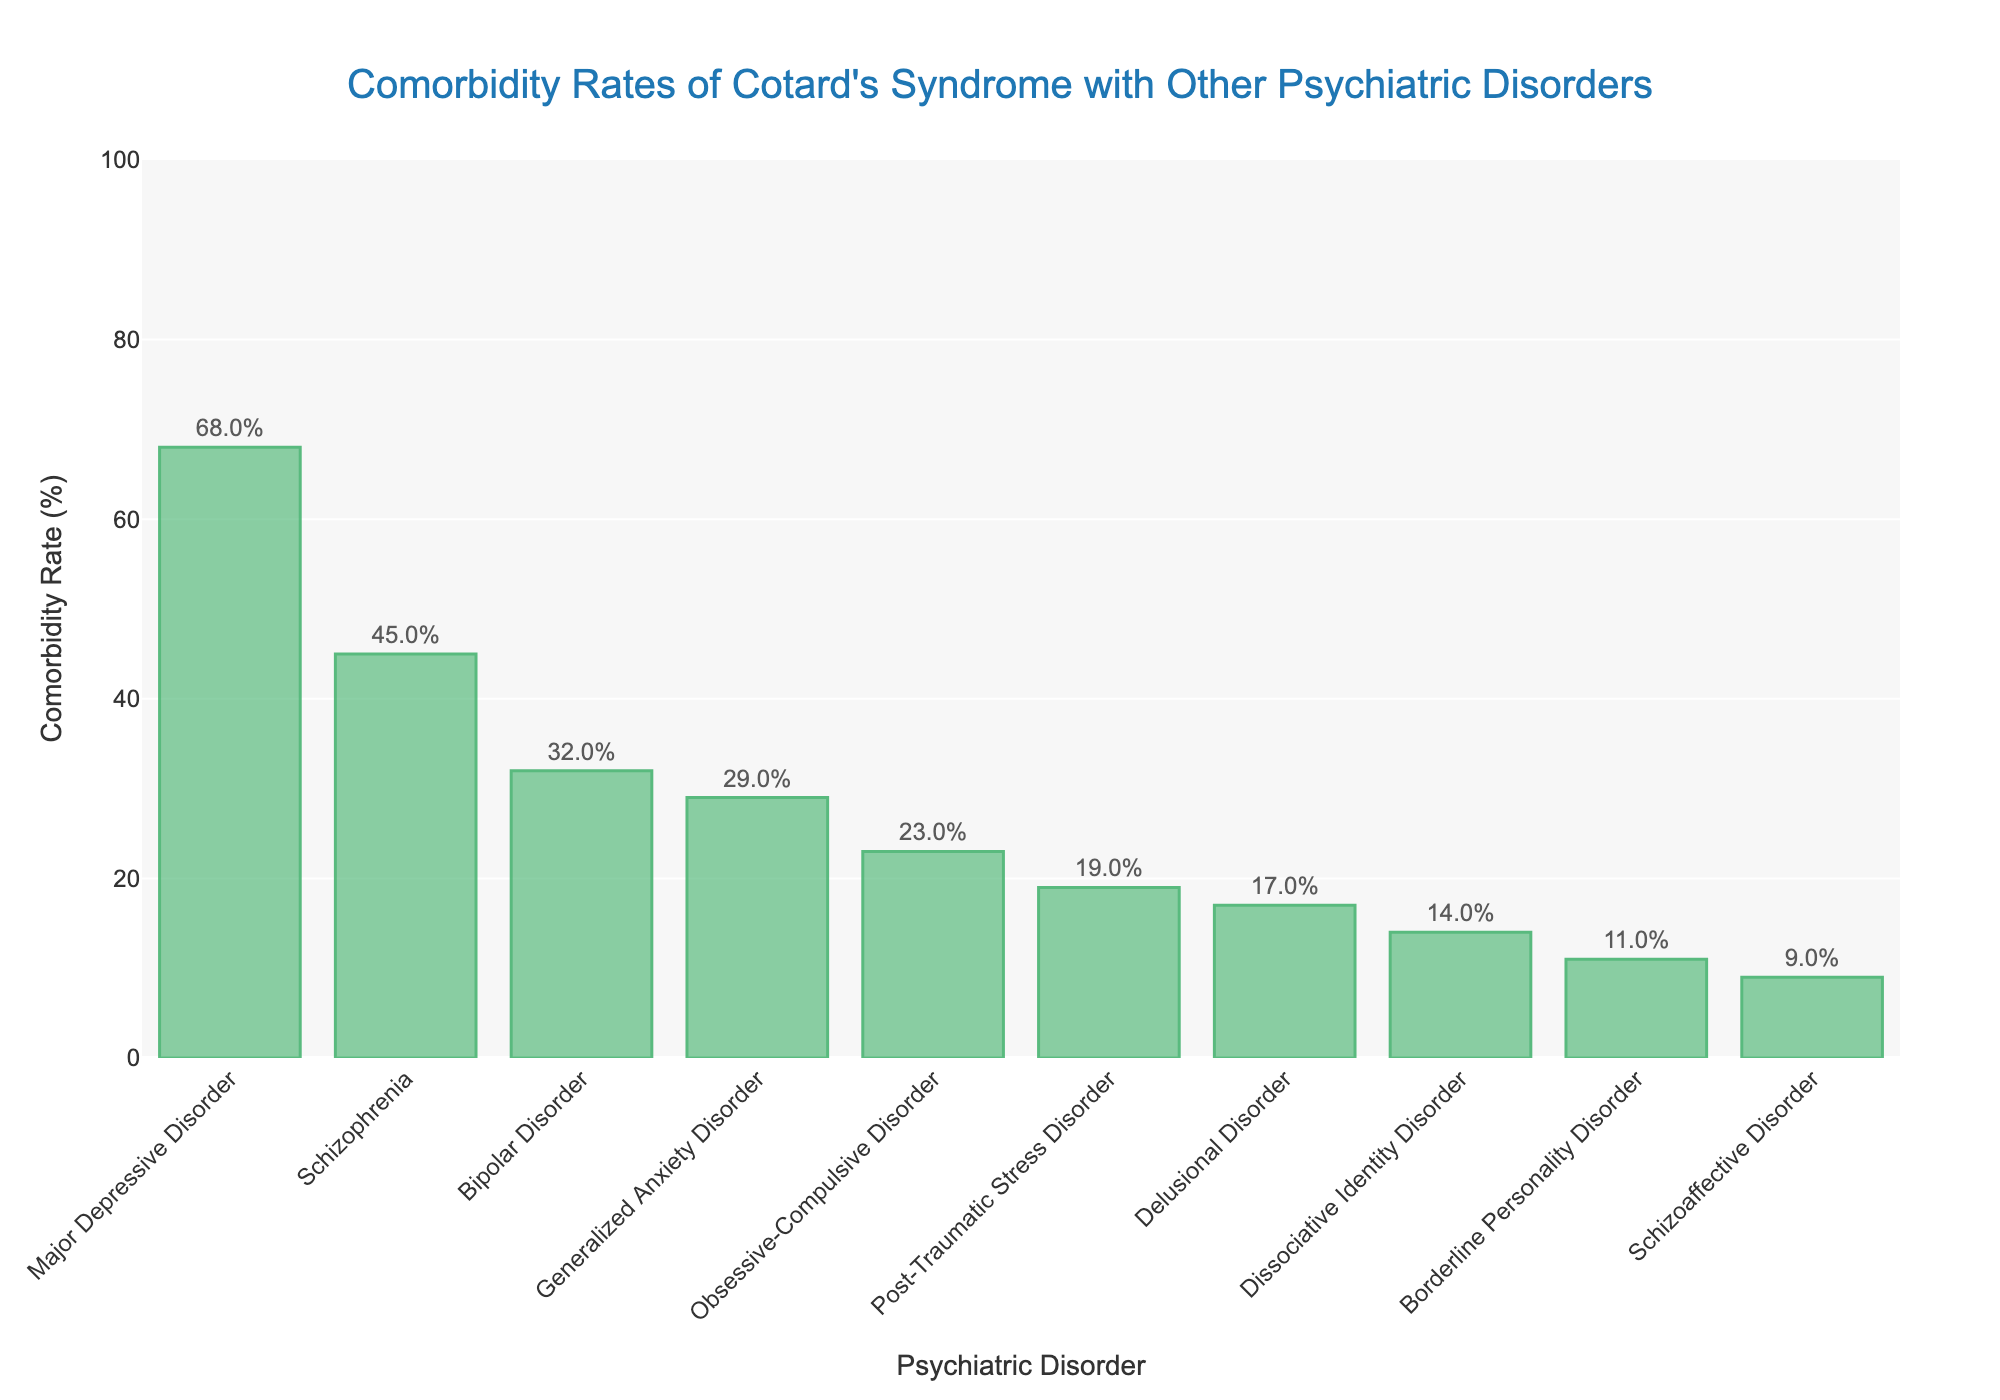Which psychiatric disorder has the highest comorbidity rate with Cotard's syndrome? The bar representing Major Depressive Disorder is the tallest among all bars in the chart.
Answer: Major Depressive Disorder What is the total comorbidity rate for Schizophrenia and Bipolar Disorder combined? The comorbidity rate for Schizophrenia is 45%, and for Bipolar Disorder, it is 32%. Adding them together, we get 45% + 32% = 77%.
Answer: 77% Which disorders have a comorbidity rate greater than 20% but less than 50%? Observing the bars, the disorders are Schizophrenia (45%), Bipolar Disorder (32%), Generalized Anxiety Disorder (29%), and Obsessive-Compulsive Disorder (23%).
Answer: Schizophrenia, Bipolar Disorder, Generalized Anxiety Disorder, Obsessive-Compulsive Disorder Order the disorders by comorbidity rate, starting from lowest to highest. Reviewing the height of the bars from shortest to tallest, we have: Schizoaffective Disorder (9%), Borderline Personality Disorder (11%), Dissociative Identity Disorder (14%), Delusional Disorder (17%), Post-Traumatic Stress Disorder (19%), Obsessive-Compulsive Disorder (23%), Generalized Anxiety Disorder (29%), Bipolar Disorder (32%), Schizophrenia (45%), and Major Depressive Disorder (68%).
Answer: Schizoaffective Disorder, Borderline Personality Disorder, Dissociative Identity Disorder, Delusional Disorder, Post-Traumatic Stress Disorder, Obsessive-Compulsive Disorder, Generalized Anxiety Disorder, Bipolar Disorder, Schizophrenia, Major Depressive Disorder What is the average comorbidity rate of all the disorders listed? Sum all the comorbidity rates: 68% + 45% + 32% + 29% + 23% + 19% + 17% + 14% + 11% + 9% = 267%. Then, divide by the number of disorders (10): 267% / 10 = 26.7%.
Answer: 26.7% How much higher is the comorbidity rate of Major Depressive Disorder compared to Generalized Anxiety Disorder? The rate of Major Depressive Disorder is 68%, and Generalized Anxiety Disorder is 29%. Subtracting these gives us 68% - 29% = 39%.
Answer: 39% Is the comorbidity rate of Obsessive-Compulsive Disorder closer to that of Bipolar Disorder or Post-Traumatic Stress Disorder? Obsessive-Compulsive Disorder has a rate of 23%, Bipolar Disorder has 32%, and Post-Traumatic Stress Disorder has 19%. The difference with Bipolar Disorder is 32% - 23% = 9%, and with Post-Traumatic Stress Disorder is 23% - 19% = 4%.
Answer: Post-Traumatic Stress Disorder 